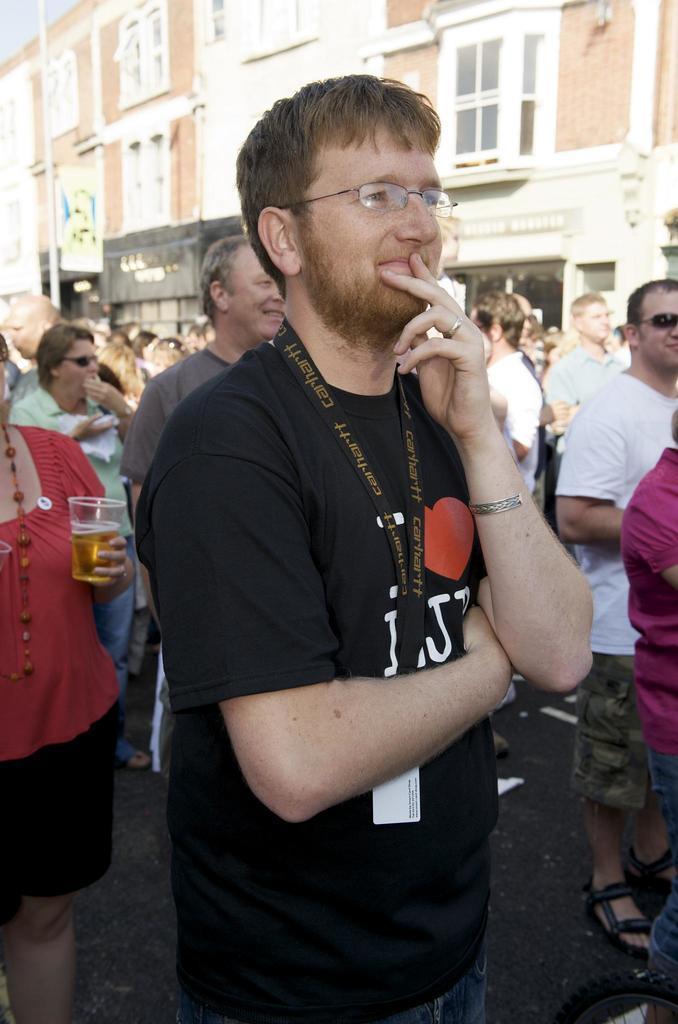Describe this image in one or two sentences. In this image there is a person standing on the road. He is wearing spectacles. Left side there is a woman holding a glass which is filled with the drink. There are people standing on the road. Background there are buildings. Left top there is sky. 